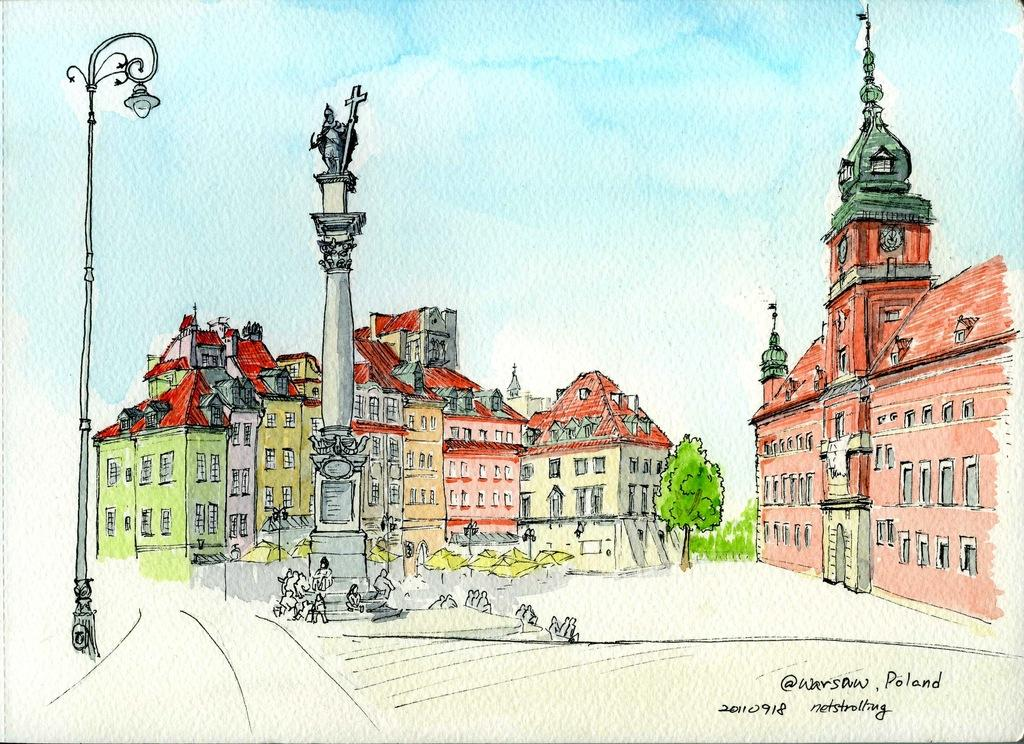What is the main subject of the image? There is a sketch in the image. What type of structures can be seen in the sketch? There are buildings in the image. What are the two vertical objects in the image? There are two poles in the image. What type of natural elements are present in the image? There are trees in the image. What is visible in the sky in the image? There are clouds in the sky. What is written at the bottom of the image? There is some text at the bottom of the image. How many bikes are parked near the buildings in the image? There are no bikes visible in the image; it only features a sketch with buildings, poles, trees, clouds, and text. What type of educational institution is depicted in the image? There is no school or educational institution depicted in the image; it only features a sketch with buildings, poles, trees, clouds, and text. 